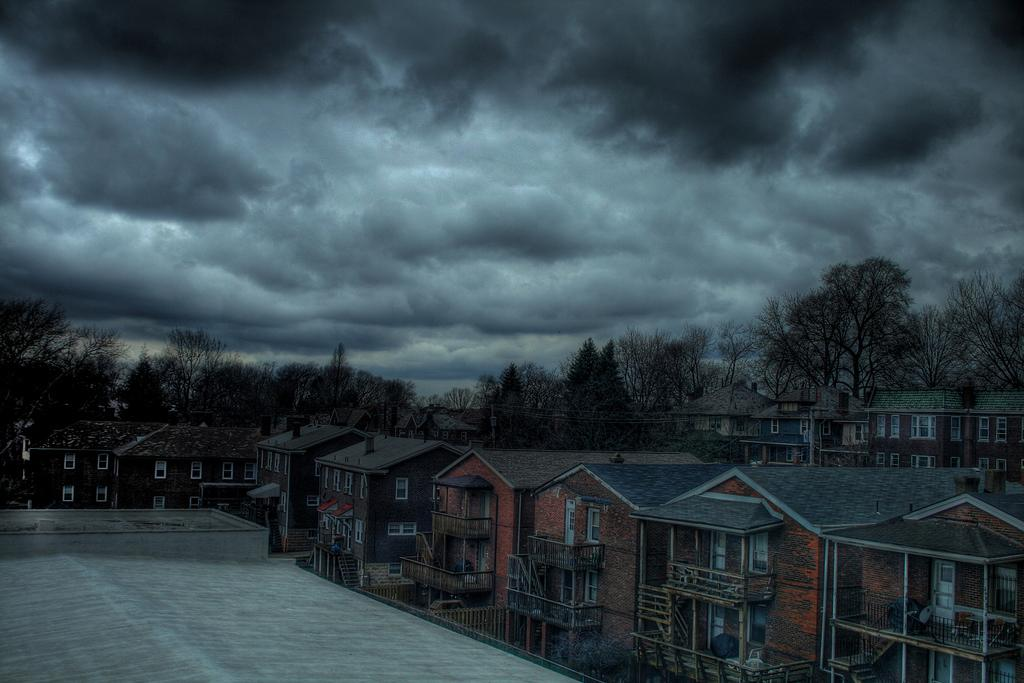What type of structures are visible in the image? There are buildings in the image. What are some features of the buildings? The buildings have walls, windows, roofs, chimneys, poles, and railings. What can be seen in the background of the image? There are trees in the background of the image. What is visible at the top of the image? The sky is visible at the top of the image. What can be observed in the sky? There are clouds in the sky. What thoughts or theories are being discussed by the women in the image? There are no women present in the image, so it is not possible to determine what thoughts or theories might be discussed. 